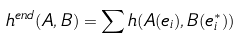Convert formula to latex. <formula><loc_0><loc_0><loc_500><loc_500>h ^ { e n d } ( A , B ) = \sum h ( A ( e _ { i } ) , B ( e ^ { * } _ { i } ) )</formula> 